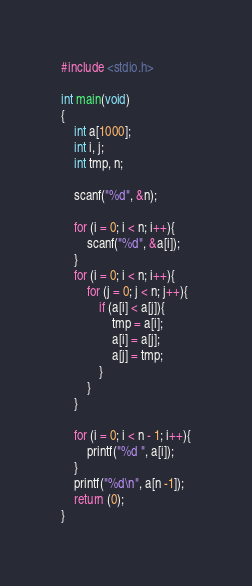Convert code to text. <code><loc_0><loc_0><loc_500><loc_500><_C_>#include <stdio.h>

int main(void)
{
	int a[1000];
	int i, j;
	int tmp, n;
	
	scanf("%d", &n);
	
	for (i = 0; i < n; i++){
		scanf("%d", &a[i]);
	}
	for (i = 0; i < n; i++){
		for (j = 0; j < n; j++){
			if (a[i] < a[j]){
				tmp = a[i];
				a[i] = a[j];
				a[j] = tmp;
			}
		}
	}
	
	for (i = 0; i < n - 1; i++){
		printf("%d ", a[i]);
	}
	printf("%d\n", a[n -1]);
	return (0);
}</code> 